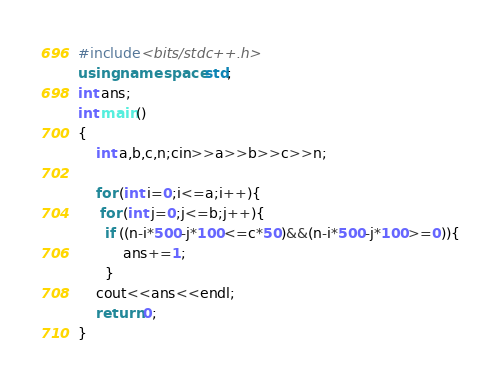<code> <loc_0><loc_0><loc_500><loc_500><_C++_>#include<bits/stdc++.h>
using namespace std;
int ans;
int main()
{
    int a,b,c,n;cin>>a>>b>>c>>n;
    
    for (int i=0;i<=a;i++){
     for (int j=0;j<=b;j++){
      if ((n-i*500-j*100<=c*50)&&(n-i*500-j*100>=0)){
          ans+=1;
      }
    cout<<ans<<endl;
    return 0;
}</code> 